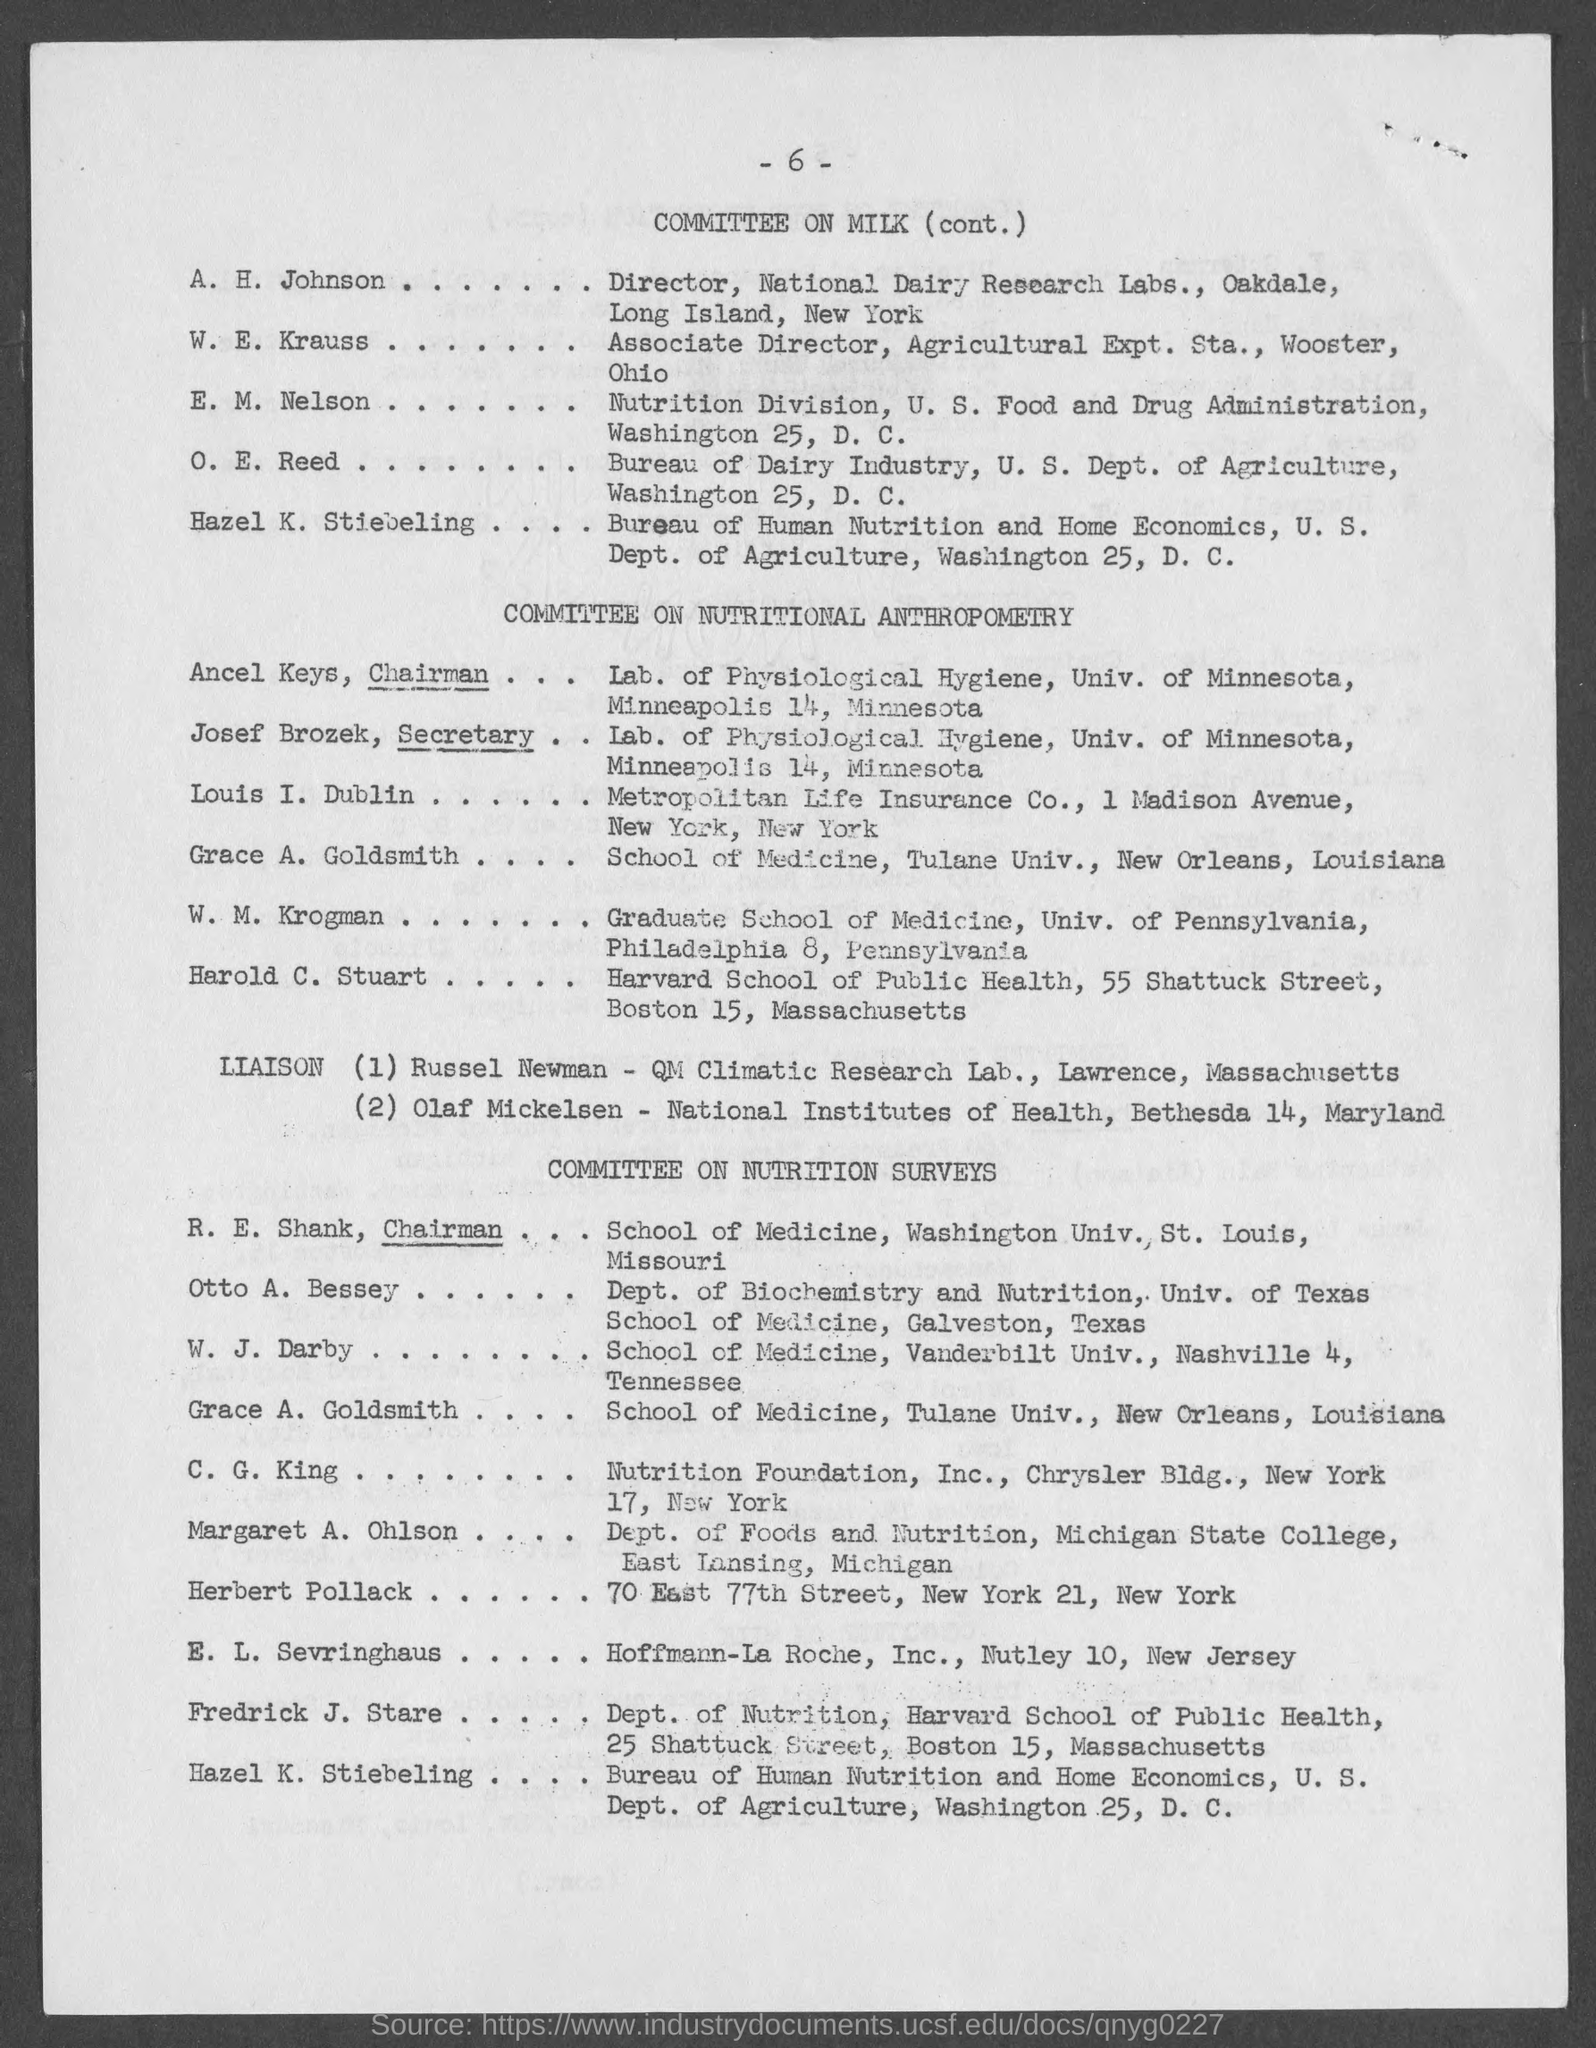Who is the Secretary of Committee on Nutritional Anthropometry?
Provide a succinct answer. Josef brozek. What is the page no given in this document?
Keep it short and to the point. 6. Who is the Chairman of Committee on Nutritional Anthropometry?
Provide a succinct answer. Ancel Keys. 